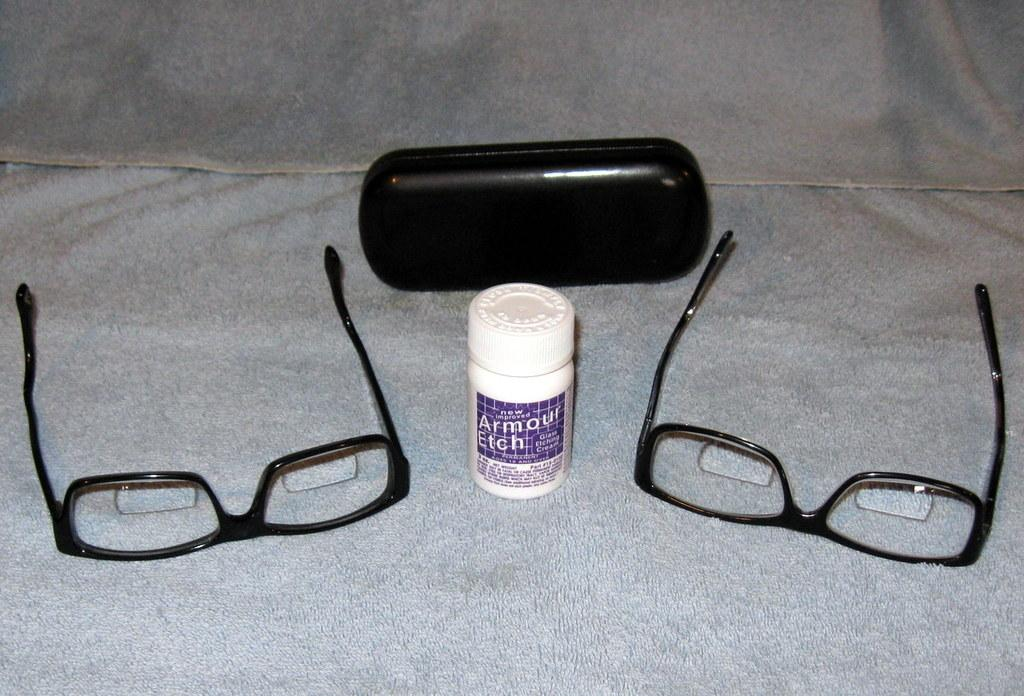What object can be seen in the image that is typically used for storage or packaging? There is a box in the image. What is the bottle with text used for? The bottle with text is likely used for holding a liquid or substance. What type of accessory is present in the image that helps with vision? Optical glasses are present in the image. How are the optical glasses placed in the image? The optical glasses are placed on a cloth. What type of crow is sitting on the bottle in the image? There is no crow present in the image; it only features a box, bottle with text, optical glasses, and a cloth. 